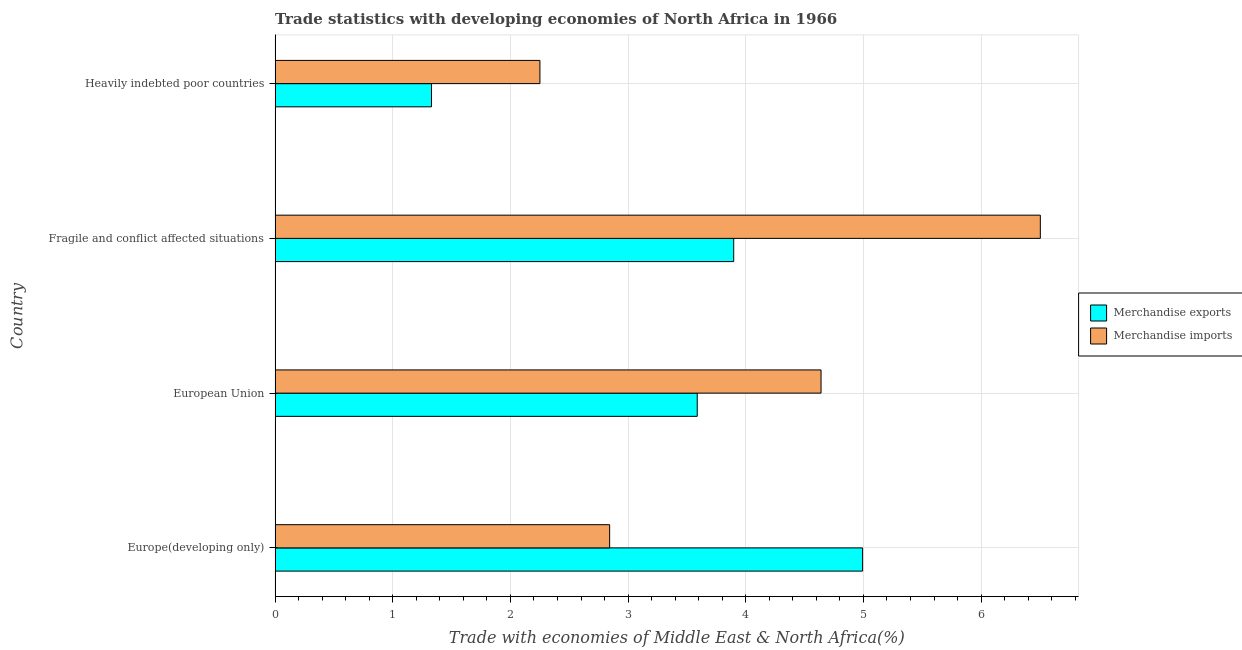How many different coloured bars are there?
Ensure brevity in your answer.  2. How many groups of bars are there?
Make the answer very short. 4. Are the number of bars per tick equal to the number of legend labels?
Offer a terse response. Yes. How many bars are there on the 2nd tick from the bottom?
Ensure brevity in your answer.  2. What is the label of the 4th group of bars from the top?
Make the answer very short. Europe(developing only). What is the merchandise exports in Heavily indebted poor countries?
Provide a short and direct response. 1.33. Across all countries, what is the maximum merchandise imports?
Make the answer very short. 6.5. Across all countries, what is the minimum merchandise exports?
Offer a terse response. 1.33. In which country was the merchandise imports maximum?
Provide a succinct answer. Fragile and conflict affected situations. In which country was the merchandise exports minimum?
Provide a short and direct response. Heavily indebted poor countries. What is the total merchandise exports in the graph?
Give a very brief answer. 13.81. What is the difference between the merchandise exports in Fragile and conflict affected situations and that in Heavily indebted poor countries?
Ensure brevity in your answer.  2.57. What is the difference between the merchandise exports in Europe(developing only) and the merchandise imports in European Union?
Offer a very short reply. 0.35. What is the average merchandise imports per country?
Keep it short and to the point. 4.06. What is the difference between the merchandise exports and merchandise imports in European Union?
Offer a very short reply. -1.05. In how many countries, is the merchandise imports greater than 4.2 %?
Make the answer very short. 2. Is the merchandise exports in Europe(developing only) less than that in Fragile and conflict affected situations?
Your response must be concise. No. Is the difference between the merchandise imports in Europe(developing only) and European Union greater than the difference between the merchandise exports in Europe(developing only) and European Union?
Offer a very short reply. No. What is the difference between the highest and the second highest merchandise imports?
Give a very brief answer. 1.86. What is the difference between the highest and the lowest merchandise exports?
Your response must be concise. 3.66. In how many countries, is the merchandise imports greater than the average merchandise imports taken over all countries?
Offer a terse response. 2. Is the sum of the merchandise exports in Europe(developing only) and European Union greater than the maximum merchandise imports across all countries?
Make the answer very short. Yes. What does the 1st bar from the bottom in Heavily indebted poor countries represents?
Keep it short and to the point. Merchandise exports. How many bars are there?
Give a very brief answer. 8. Are all the bars in the graph horizontal?
Provide a short and direct response. Yes. How many countries are there in the graph?
Give a very brief answer. 4. Are the values on the major ticks of X-axis written in scientific E-notation?
Offer a terse response. No. Does the graph contain any zero values?
Offer a terse response. No. How many legend labels are there?
Your answer should be very brief. 2. What is the title of the graph?
Your response must be concise. Trade statistics with developing economies of North Africa in 1966. Does "Automatic Teller Machines" appear as one of the legend labels in the graph?
Give a very brief answer. No. What is the label or title of the X-axis?
Keep it short and to the point. Trade with economies of Middle East & North Africa(%). What is the label or title of the Y-axis?
Offer a very short reply. Country. What is the Trade with economies of Middle East & North Africa(%) of Merchandise exports in Europe(developing only)?
Offer a terse response. 4.99. What is the Trade with economies of Middle East & North Africa(%) of Merchandise imports in Europe(developing only)?
Your response must be concise. 2.84. What is the Trade with economies of Middle East & North Africa(%) of Merchandise exports in European Union?
Your response must be concise. 3.59. What is the Trade with economies of Middle East & North Africa(%) of Merchandise imports in European Union?
Ensure brevity in your answer.  4.64. What is the Trade with economies of Middle East & North Africa(%) of Merchandise exports in Fragile and conflict affected situations?
Offer a very short reply. 3.9. What is the Trade with economies of Middle East & North Africa(%) in Merchandise imports in Fragile and conflict affected situations?
Your answer should be compact. 6.5. What is the Trade with economies of Middle East & North Africa(%) in Merchandise exports in Heavily indebted poor countries?
Your answer should be compact. 1.33. What is the Trade with economies of Middle East & North Africa(%) in Merchandise imports in Heavily indebted poor countries?
Make the answer very short. 2.25. Across all countries, what is the maximum Trade with economies of Middle East & North Africa(%) in Merchandise exports?
Offer a terse response. 4.99. Across all countries, what is the maximum Trade with economies of Middle East & North Africa(%) of Merchandise imports?
Offer a terse response. 6.5. Across all countries, what is the minimum Trade with economies of Middle East & North Africa(%) of Merchandise exports?
Offer a terse response. 1.33. Across all countries, what is the minimum Trade with economies of Middle East & North Africa(%) of Merchandise imports?
Your answer should be very brief. 2.25. What is the total Trade with economies of Middle East & North Africa(%) in Merchandise exports in the graph?
Your answer should be very brief. 13.81. What is the total Trade with economies of Middle East & North Africa(%) of Merchandise imports in the graph?
Ensure brevity in your answer.  16.24. What is the difference between the Trade with economies of Middle East & North Africa(%) of Merchandise exports in Europe(developing only) and that in European Union?
Your response must be concise. 1.41. What is the difference between the Trade with economies of Middle East & North Africa(%) in Merchandise imports in Europe(developing only) and that in European Union?
Offer a very short reply. -1.8. What is the difference between the Trade with economies of Middle East & North Africa(%) of Merchandise exports in Europe(developing only) and that in Fragile and conflict affected situations?
Make the answer very short. 1.1. What is the difference between the Trade with economies of Middle East & North Africa(%) of Merchandise imports in Europe(developing only) and that in Fragile and conflict affected situations?
Provide a succinct answer. -3.66. What is the difference between the Trade with economies of Middle East & North Africa(%) of Merchandise exports in Europe(developing only) and that in Heavily indebted poor countries?
Offer a terse response. 3.66. What is the difference between the Trade with economies of Middle East & North Africa(%) in Merchandise imports in Europe(developing only) and that in Heavily indebted poor countries?
Offer a very short reply. 0.59. What is the difference between the Trade with economies of Middle East & North Africa(%) of Merchandise exports in European Union and that in Fragile and conflict affected situations?
Your answer should be very brief. -0.31. What is the difference between the Trade with economies of Middle East & North Africa(%) in Merchandise imports in European Union and that in Fragile and conflict affected situations?
Offer a terse response. -1.86. What is the difference between the Trade with economies of Middle East & North Africa(%) of Merchandise exports in European Union and that in Heavily indebted poor countries?
Provide a short and direct response. 2.26. What is the difference between the Trade with economies of Middle East & North Africa(%) in Merchandise imports in European Union and that in Heavily indebted poor countries?
Keep it short and to the point. 2.39. What is the difference between the Trade with economies of Middle East & North Africa(%) in Merchandise exports in Fragile and conflict affected situations and that in Heavily indebted poor countries?
Ensure brevity in your answer.  2.57. What is the difference between the Trade with economies of Middle East & North Africa(%) in Merchandise imports in Fragile and conflict affected situations and that in Heavily indebted poor countries?
Offer a very short reply. 4.25. What is the difference between the Trade with economies of Middle East & North Africa(%) in Merchandise exports in Europe(developing only) and the Trade with economies of Middle East & North Africa(%) in Merchandise imports in European Union?
Make the answer very short. 0.35. What is the difference between the Trade with economies of Middle East & North Africa(%) of Merchandise exports in Europe(developing only) and the Trade with economies of Middle East & North Africa(%) of Merchandise imports in Fragile and conflict affected situations?
Offer a terse response. -1.51. What is the difference between the Trade with economies of Middle East & North Africa(%) in Merchandise exports in Europe(developing only) and the Trade with economies of Middle East & North Africa(%) in Merchandise imports in Heavily indebted poor countries?
Offer a very short reply. 2.74. What is the difference between the Trade with economies of Middle East & North Africa(%) of Merchandise exports in European Union and the Trade with economies of Middle East & North Africa(%) of Merchandise imports in Fragile and conflict affected situations?
Ensure brevity in your answer.  -2.92. What is the difference between the Trade with economies of Middle East & North Africa(%) in Merchandise exports in European Union and the Trade with economies of Middle East & North Africa(%) in Merchandise imports in Heavily indebted poor countries?
Provide a succinct answer. 1.34. What is the difference between the Trade with economies of Middle East & North Africa(%) in Merchandise exports in Fragile and conflict affected situations and the Trade with economies of Middle East & North Africa(%) in Merchandise imports in Heavily indebted poor countries?
Your answer should be very brief. 1.65. What is the average Trade with economies of Middle East & North Africa(%) in Merchandise exports per country?
Provide a short and direct response. 3.45. What is the average Trade with economies of Middle East & North Africa(%) of Merchandise imports per country?
Offer a terse response. 4.06. What is the difference between the Trade with economies of Middle East & North Africa(%) in Merchandise exports and Trade with economies of Middle East & North Africa(%) in Merchandise imports in Europe(developing only)?
Offer a terse response. 2.15. What is the difference between the Trade with economies of Middle East & North Africa(%) in Merchandise exports and Trade with economies of Middle East & North Africa(%) in Merchandise imports in European Union?
Provide a succinct answer. -1.05. What is the difference between the Trade with economies of Middle East & North Africa(%) in Merchandise exports and Trade with economies of Middle East & North Africa(%) in Merchandise imports in Fragile and conflict affected situations?
Your response must be concise. -2.61. What is the difference between the Trade with economies of Middle East & North Africa(%) of Merchandise exports and Trade with economies of Middle East & North Africa(%) of Merchandise imports in Heavily indebted poor countries?
Provide a succinct answer. -0.92. What is the ratio of the Trade with economies of Middle East & North Africa(%) of Merchandise exports in Europe(developing only) to that in European Union?
Provide a short and direct response. 1.39. What is the ratio of the Trade with economies of Middle East & North Africa(%) of Merchandise imports in Europe(developing only) to that in European Union?
Give a very brief answer. 0.61. What is the ratio of the Trade with economies of Middle East & North Africa(%) in Merchandise exports in Europe(developing only) to that in Fragile and conflict affected situations?
Keep it short and to the point. 1.28. What is the ratio of the Trade with economies of Middle East & North Africa(%) of Merchandise imports in Europe(developing only) to that in Fragile and conflict affected situations?
Provide a short and direct response. 0.44. What is the ratio of the Trade with economies of Middle East & North Africa(%) in Merchandise exports in Europe(developing only) to that in Heavily indebted poor countries?
Give a very brief answer. 3.76. What is the ratio of the Trade with economies of Middle East & North Africa(%) of Merchandise imports in Europe(developing only) to that in Heavily indebted poor countries?
Ensure brevity in your answer.  1.26. What is the ratio of the Trade with economies of Middle East & North Africa(%) in Merchandise exports in European Union to that in Fragile and conflict affected situations?
Give a very brief answer. 0.92. What is the ratio of the Trade with economies of Middle East & North Africa(%) in Merchandise imports in European Union to that in Fragile and conflict affected situations?
Provide a succinct answer. 0.71. What is the ratio of the Trade with economies of Middle East & North Africa(%) in Merchandise exports in European Union to that in Heavily indebted poor countries?
Provide a short and direct response. 2.7. What is the ratio of the Trade with economies of Middle East & North Africa(%) in Merchandise imports in European Union to that in Heavily indebted poor countries?
Make the answer very short. 2.06. What is the ratio of the Trade with economies of Middle East & North Africa(%) in Merchandise exports in Fragile and conflict affected situations to that in Heavily indebted poor countries?
Ensure brevity in your answer.  2.93. What is the ratio of the Trade with economies of Middle East & North Africa(%) of Merchandise imports in Fragile and conflict affected situations to that in Heavily indebted poor countries?
Ensure brevity in your answer.  2.89. What is the difference between the highest and the second highest Trade with economies of Middle East & North Africa(%) in Merchandise exports?
Ensure brevity in your answer.  1.1. What is the difference between the highest and the second highest Trade with economies of Middle East & North Africa(%) in Merchandise imports?
Make the answer very short. 1.86. What is the difference between the highest and the lowest Trade with economies of Middle East & North Africa(%) in Merchandise exports?
Ensure brevity in your answer.  3.66. What is the difference between the highest and the lowest Trade with economies of Middle East & North Africa(%) in Merchandise imports?
Keep it short and to the point. 4.25. 